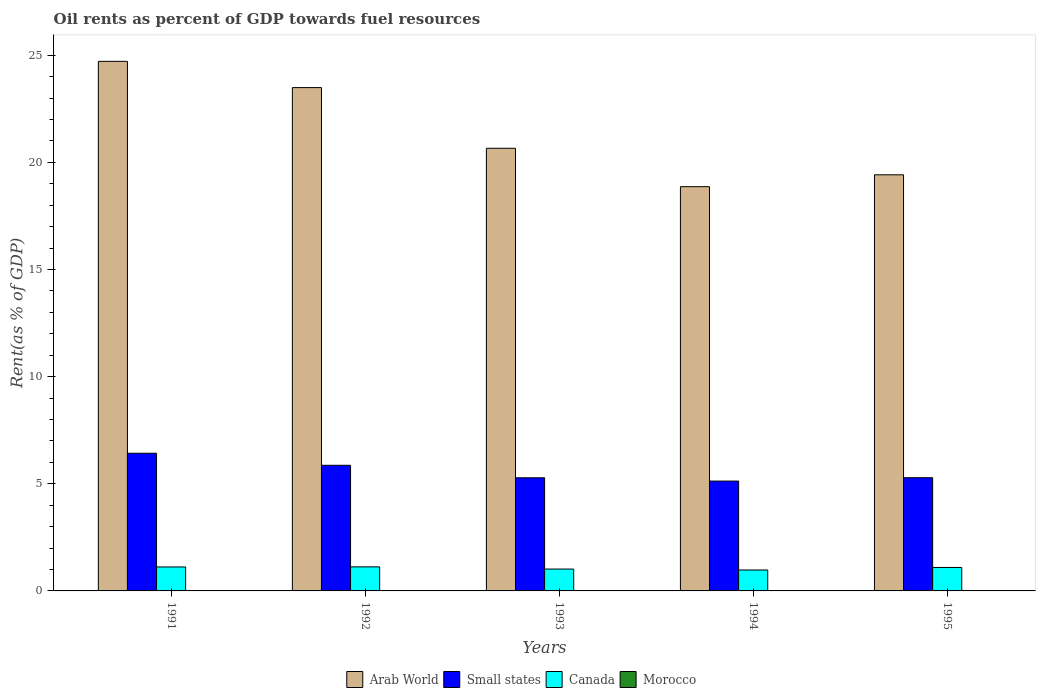How many groups of bars are there?
Provide a short and direct response. 5. Are the number of bars on each tick of the X-axis equal?
Keep it short and to the point. Yes. How many bars are there on the 5th tick from the left?
Make the answer very short. 4. In how many cases, is the number of bars for a given year not equal to the number of legend labels?
Ensure brevity in your answer.  0. What is the oil rent in Arab World in 1995?
Keep it short and to the point. 19.42. Across all years, what is the maximum oil rent in Morocco?
Give a very brief answer. 0. Across all years, what is the minimum oil rent in Arab World?
Your response must be concise. 18.86. In which year was the oil rent in Morocco maximum?
Offer a very short reply. 1991. What is the total oil rent in Arab World in the graph?
Provide a succinct answer. 107.13. What is the difference between the oil rent in Morocco in 1993 and that in 1995?
Your answer should be compact. 0. What is the difference between the oil rent in Arab World in 1993 and the oil rent in Small states in 1994?
Your response must be concise. 15.53. What is the average oil rent in Canada per year?
Give a very brief answer. 1.07. In the year 1991, what is the difference between the oil rent in Morocco and oil rent in Small states?
Your answer should be compact. -6.42. In how many years, is the oil rent in Morocco greater than 10 %?
Make the answer very short. 0. What is the ratio of the oil rent in Small states in 1993 to that in 1994?
Provide a short and direct response. 1.03. Is the oil rent in Morocco in 1993 less than that in 1995?
Provide a succinct answer. No. Is the difference between the oil rent in Morocco in 1992 and 1995 greater than the difference between the oil rent in Small states in 1992 and 1995?
Provide a short and direct response. No. What is the difference between the highest and the second highest oil rent in Canada?
Give a very brief answer. 0. What is the difference between the highest and the lowest oil rent in Canada?
Give a very brief answer. 0.15. In how many years, is the oil rent in Arab World greater than the average oil rent in Arab World taken over all years?
Provide a short and direct response. 2. Is the sum of the oil rent in Small states in 1994 and 1995 greater than the maximum oil rent in Morocco across all years?
Your answer should be very brief. Yes. Is it the case that in every year, the sum of the oil rent in Canada and oil rent in Small states is greater than the sum of oil rent in Morocco and oil rent in Arab World?
Your answer should be very brief. No. What does the 1st bar from the left in 1995 represents?
Ensure brevity in your answer.  Arab World. What does the 4th bar from the right in 1995 represents?
Ensure brevity in your answer.  Arab World. Is it the case that in every year, the sum of the oil rent in Canada and oil rent in Morocco is greater than the oil rent in Small states?
Your answer should be very brief. No. How many bars are there?
Your answer should be compact. 20. How many years are there in the graph?
Provide a succinct answer. 5. Does the graph contain any zero values?
Your response must be concise. No. Where does the legend appear in the graph?
Offer a terse response. Bottom center. How are the legend labels stacked?
Your answer should be very brief. Horizontal. What is the title of the graph?
Offer a terse response. Oil rents as percent of GDP towards fuel resources. Does "Micronesia" appear as one of the legend labels in the graph?
Keep it short and to the point. No. What is the label or title of the Y-axis?
Your answer should be very brief. Rent(as % of GDP). What is the Rent(as % of GDP) in Arab World in 1991?
Your response must be concise. 24.71. What is the Rent(as % of GDP) in Small states in 1991?
Provide a short and direct response. 6.42. What is the Rent(as % of GDP) in Canada in 1991?
Ensure brevity in your answer.  1.12. What is the Rent(as % of GDP) of Morocco in 1991?
Offer a terse response. 0. What is the Rent(as % of GDP) in Arab World in 1992?
Keep it short and to the point. 23.49. What is the Rent(as % of GDP) in Small states in 1992?
Your answer should be compact. 5.86. What is the Rent(as % of GDP) of Canada in 1992?
Your answer should be compact. 1.12. What is the Rent(as % of GDP) of Morocco in 1992?
Your answer should be compact. 0. What is the Rent(as % of GDP) in Arab World in 1993?
Ensure brevity in your answer.  20.66. What is the Rent(as % of GDP) of Small states in 1993?
Offer a very short reply. 5.28. What is the Rent(as % of GDP) of Canada in 1993?
Provide a short and direct response. 1.02. What is the Rent(as % of GDP) of Morocco in 1993?
Ensure brevity in your answer.  0. What is the Rent(as % of GDP) of Arab World in 1994?
Offer a terse response. 18.86. What is the Rent(as % of GDP) in Small states in 1994?
Make the answer very short. 5.13. What is the Rent(as % of GDP) in Canada in 1994?
Ensure brevity in your answer.  0.98. What is the Rent(as % of GDP) in Morocco in 1994?
Offer a terse response. 0. What is the Rent(as % of GDP) in Arab World in 1995?
Offer a terse response. 19.42. What is the Rent(as % of GDP) of Small states in 1995?
Ensure brevity in your answer.  5.28. What is the Rent(as % of GDP) in Canada in 1995?
Provide a succinct answer. 1.09. What is the Rent(as % of GDP) in Morocco in 1995?
Your answer should be very brief. 0. Across all years, what is the maximum Rent(as % of GDP) in Arab World?
Give a very brief answer. 24.71. Across all years, what is the maximum Rent(as % of GDP) of Small states?
Ensure brevity in your answer.  6.42. Across all years, what is the maximum Rent(as % of GDP) in Canada?
Provide a succinct answer. 1.12. Across all years, what is the maximum Rent(as % of GDP) in Morocco?
Offer a very short reply. 0. Across all years, what is the minimum Rent(as % of GDP) in Arab World?
Ensure brevity in your answer.  18.86. Across all years, what is the minimum Rent(as % of GDP) of Small states?
Your response must be concise. 5.13. Across all years, what is the minimum Rent(as % of GDP) in Canada?
Your answer should be compact. 0.98. Across all years, what is the minimum Rent(as % of GDP) in Morocco?
Keep it short and to the point. 0. What is the total Rent(as % of GDP) in Arab World in the graph?
Your answer should be very brief. 107.13. What is the total Rent(as % of GDP) of Small states in the graph?
Ensure brevity in your answer.  27.97. What is the total Rent(as % of GDP) in Canada in the graph?
Ensure brevity in your answer.  5.33. What is the total Rent(as % of GDP) in Morocco in the graph?
Ensure brevity in your answer.  0.02. What is the difference between the Rent(as % of GDP) of Arab World in 1991 and that in 1992?
Make the answer very short. 1.22. What is the difference between the Rent(as % of GDP) of Small states in 1991 and that in 1992?
Offer a very short reply. 0.56. What is the difference between the Rent(as % of GDP) in Canada in 1991 and that in 1992?
Keep it short and to the point. -0. What is the difference between the Rent(as % of GDP) of Morocco in 1991 and that in 1992?
Your answer should be very brief. 0. What is the difference between the Rent(as % of GDP) in Arab World in 1991 and that in 1993?
Your response must be concise. 4.06. What is the difference between the Rent(as % of GDP) in Small states in 1991 and that in 1993?
Ensure brevity in your answer.  1.15. What is the difference between the Rent(as % of GDP) in Canada in 1991 and that in 1993?
Your answer should be compact. 0.1. What is the difference between the Rent(as % of GDP) in Morocco in 1991 and that in 1993?
Your response must be concise. 0. What is the difference between the Rent(as % of GDP) in Arab World in 1991 and that in 1994?
Give a very brief answer. 5.85. What is the difference between the Rent(as % of GDP) in Small states in 1991 and that in 1994?
Ensure brevity in your answer.  1.3. What is the difference between the Rent(as % of GDP) of Canada in 1991 and that in 1994?
Provide a short and direct response. 0.14. What is the difference between the Rent(as % of GDP) of Morocco in 1991 and that in 1994?
Make the answer very short. 0. What is the difference between the Rent(as % of GDP) of Arab World in 1991 and that in 1995?
Provide a succinct answer. 5.29. What is the difference between the Rent(as % of GDP) in Small states in 1991 and that in 1995?
Provide a succinct answer. 1.14. What is the difference between the Rent(as % of GDP) in Canada in 1991 and that in 1995?
Keep it short and to the point. 0.02. What is the difference between the Rent(as % of GDP) in Morocco in 1991 and that in 1995?
Your response must be concise. 0. What is the difference between the Rent(as % of GDP) of Arab World in 1992 and that in 1993?
Your response must be concise. 2.83. What is the difference between the Rent(as % of GDP) in Small states in 1992 and that in 1993?
Your answer should be very brief. 0.58. What is the difference between the Rent(as % of GDP) in Canada in 1992 and that in 1993?
Offer a terse response. 0.1. What is the difference between the Rent(as % of GDP) in Morocco in 1992 and that in 1993?
Offer a terse response. 0. What is the difference between the Rent(as % of GDP) in Arab World in 1992 and that in 1994?
Your answer should be very brief. 4.62. What is the difference between the Rent(as % of GDP) of Small states in 1992 and that in 1994?
Offer a terse response. 0.74. What is the difference between the Rent(as % of GDP) of Canada in 1992 and that in 1994?
Provide a short and direct response. 0.15. What is the difference between the Rent(as % of GDP) in Morocco in 1992 and that in 1994?
Provide a short and direct response. 0. What is the difference between the Rent(as % of GDP) of Arab World in 1992 and that in 1995?
Make the answer very short. 4.07. What is the difference between the Rent(as % of GDP) of Small states in 1992 and that in 1995?
Provide a short and direct response. 0.58. What is the difference between the Rent(as % of GDP) in Canada in 1992 and that in 1995?
Provide a succinct answer. 0.03. What is the difference between the Rent(as % of GDP) of Morocco in 1992 and that in 1995?
Your response must be concise. 0. What is the difference between the Rent(as % of GDP) of Arab World in 1993 and that in 1994?
Give a very brief answer. 1.79. What is the difference between the Rent(as % of GDP) of Small states in 1993 and that in 1994?
Your answer should be very brief. 0.15. What is the difference between the Rent(as % of GDP) of Canada in 1993 and that in 1994?
Provide a short and direct response. 0.04. What is the difference between the Rent(as % of GDP) of Morocco in 1993 and that in 1994?
Keep it short and to the point. 0. What is the difference between the Rent(as % of GDP) in Arab World in 1993 and that in 1995?
Make the answer very short. 1.24. What is the difference between the Rent(as % of GDP) of Small states in 1993 and that in 1995?
Provide a succinct answer. -0. What is the difference between the Rent(as % of GDP) in Canada in 1993 and that in 1995?
Your answer should be very brief. -0.07. What is the difference between the Rent(as % of GDP) in Morocco in 1993 and that in 1995?
Give a very brief answer. 0. What is the difference between the Rent(as % of GDP) of Arab World in 1994 and that in 1995?
Your response must be concise. -0.55. What is the difference between the Rent(as % of GDP) of Small states in 1994 and that in 1995?
Your answer should be very brief. -0.16. What is the difference between the Rent(as % of GDP) in Canada in 1994 and that in 1995?
Offer a terse response. -0.12. What is the difference between the Rent(as % of GDP) of Morocco in 1994 and that in 1995?
Provide a short and direct response. 0. What is the difference between the Rent(as % of GDP) of Arab World in 1991 and the Rent(as % of GDP) of Small states in 1992?
Your answer should be very brief. 18.85. What is the difference between the Rent(as % of GDP) of Arab World in 1991 and the Rent(as % of GDP) of Canada in 1992?
Provide a short and direct response. 23.59. What is the difference between the Rent(as % of GDP) of Arab World in 1991 and the Rent(as % of GDP) of Morocco in 1992?
Give a very brief answer. 24.71. What is the difference between the Rent(as % of GDP) in Small states in 1991 and the Rent(as % of GDP) in Canada in 1992?
Give a very brief answer. 5.3. What is the difference between the Rent(as % of GDP) of Small states in 1991 and the Rent(as % of GDP) of Morocco in 1992?
Keep it short and to the point. 6.42. What is the difference between the Rent(as % of GDP) of Canada in 1991 and the Rent(as % of GDP) of Morocco in 1992?
Give a very brief answer. 1.11. What is the difference between the Rent(as % of GDP) in Arab World in 1991 and the Rent(as % of GDP) in Small states in 1993?
Your response must be concise. 19.43. What is the difference between the Rent(as % of GDP) of Arab World in 1991 and the Rent(as % of GDP) of Canada in 1993?
Your answer should be very brief. 23.69. What is the difference between the Rent(as % of GDP) in Arab World in 1991 and the Rent(as % of GDP) in Morocco in 1993?
Provide a short and direct response. 24.71. What is the difference between the Rent(as % of GDP) of Small states in 1991 and the Rent(as % of GDP) of Canada in 1993?
Offer a very short reply. 5.4. What is the difference between the Rent(as % of GDP) in Small states in 1991 and the Rent(as % of GDP) in Morocco in 1993?
Keep it short and to the point. 6.42. What is the difference between the Rent(as % of GDP) in Canada in 1991 and the Rent(as % of GDP) in Morocco in 1993?
Your response must be concise. 1.12. What is the difference between the Rent(as % of GDP) of Arab World in 1991 and the Rent(as % of GDP) of Small states in 1994?
Your answer should be compact. 19.59. What is the difference between the Rent(as % of GDP) in Arab World in 1991 and the Rent(as % of GDP) in Canada in 1994?
Provide a short and direct response. 23.73. What is the difference between the Rent(as % of GDP) in Arab World in 1991 and the Rent(as % of GDP) in Morocco in 1994?
Your answer should be very brief. 24.71. What is the difference between the Rent(as % of GDP) in Small states in 1991 and the Rent(as % of GDP) in Canada in 1994?
Provide a succinct answer. 5.45. What is the difference between the Rent(as % of GDP) of Small states in 1991 and the Rent(as % of GDP) of Morocco in 1994?
Provide a short and direct response. 6.42. What is the difference between the Rent(as % of GDP) in Canada in 1991 and the Rent(as % of GDP) in Morocco in 1994?
Your answer should be very brief. 1.12. What is the difference between the Rent(as % of GDP) of Arab World in 1991 and the Rent(as % of GDP) of Small states in 1995?
Your answer should be compact. 19.43. What is the difference between the Rent(as % of GDP) of Arab World in 1991 and the Rent(as % of GDP) of Canada in 1995?
Provide a short and direct response. 23.62. What is the difference between the Rent(as % of GDP) of Arab World in 1991 and the Rent(as % of GDP) of Morocco in 1995?
Keep it short and to the point. 24.71. What is the difference between the Rent(as % of GDP) in Small states in 1991 and the Rent(as % of GDP) in Canada in 1995?
Your answer should be very brief. 5.33. What is the difference between the Rent(as % of GDP) of Small states in 1991 and the Rent(as % of GDP) of Morocco in 1995?
Ensure brevity in your answer.  6.42. What is the difference between the Rent(as % of GDP) of Canada in 1991 and the Rent(as % of GDP) of Morocco in 1995?
Your answer should be compact. 1.12. What is the difference between the Rent(as % of GDP) of Arab World in 1992 and the Rent(as % of GDP) of Small states in 1993?
Keep it short and to the point. 18.21. What is the difference between the Rent(as % of GDP) in Arab World in 1992 and the Rent(as % of GDP) in Canada in 1993?
Keep it short and to the point. 22.47. What is the difference between the Rent(as % of GDP) of Arab World in 1992 and the Rent(as % of GDP) of Morocco in 1993?
Make the answer very short. 23.48. What is the difference between the Rent(as % of GDP) in Small states in 1992 and the Rent(as % of GDP) in Canada in 1993?
Provide a succinct answer. 4.84. What is the difference between the Rent(as % of GDP) of Small states in 1992 and the Rent(as % of GDP) of Morocco in 1993?
Your answer should be compact. 5.86. What is the difference between the Rent(as % of GDP) of Canada in 1992 and the Rent(as % of GDP) of Morocco in 1993?
Provide a short and direct response. 1.12. What is the difference between the Rent(as % of GDP) of Arab World in 1992 and the Rent(as % of GDP) of Small states in 1994?
Offer a very short reply. 18.36. What is the difference between the Rent(as % of GDP) in Arab World in 1992 and the Rent(as % of GDP) in Canada in 1994?
Offer a terse response. 22.51. What is the difference between the Rent(as % of GDP) of Arab World in 1992 and the Rent(as % of GDP) of Morocco in 1994?
Provide a short and direct response. 23.48. What is the difference between the Rent(as % of GDP) in Small states in 1992 and the Rent(as % of GDP) in Canada in 1994?
Offer a very short reply. 4.89. What is the difference between the Rent(as % of GDP) in Small states in 1992 and the Rent(as % of GDP) in Morocco in 1994?
Provide a short and direct response. 5.86. What is the difference between the Rent(as % of GDP) of Canada in 1992 and the Rent(as % of GDP) of Morocco in 1994?
Your response must be concise. 1.12. What is the difference between the Rent(as % of GDP) of Arab World in 1992 and the Rent(as % of GDP) of Small states in 1995?
Give a very brief answer. 18.2. What is the difference between the Rent(as % of GDP) in Arab World in 1992 and the Rent(as % of GDP) in Canada in 1995?
Make the answer very short. 22.39. What is the difference between the Rent(as % of GDP) in Arab World in 1992 and the Rent(as % of GDP) in Morocco in 1995?
Your answer should be very brief. 23.48. What is the difference between the Rent(as % of GDP) in Small states in 1992 and the Rent(as % of GDP) in Canada in 1995?
Ensure brevity in your answer.  4.77. What is the difference between the Rent(as % of GDP) of Small states in 1992 and the Rent(as % of GDP) of Morocco in 1995?
Offer a very short reply. 5.86. What is the difference between the Rent(as % of GDP) in Canada in 1992 and the Rent(as % of GDP) in Morocco in 1995?
Offer a terse response. 1.12. What is the difference between the Rent(as % of GDP) of Arab World in 1993 and the Rent(as % of GDP) of Small states in 1994?
Ensure brevity in your answer.  15.53. What is the difference between the Rent(as % of GDP) in Arab World in 1993 and the Rent(as % of GDP) in Canada in 1994?
Provide a succinct answer. 19.68. What is the difference between the Rent(as % of GDP) in Arab World in 1993 and the Rent(as % of GDP) in Morocco in 1994?
Provide a short and direct response. 20.65. What is the difference between the Rent(as % of GDP) in Small states in 1993 and the Rent(as % of GDP) in Canada in 1994?
Offer a very short reply. 4.3. What is the difference between the Rent(as % of GDP) in Small states in 1993 and the Rent(as % of GDP) in Morocco in 1994?
Provide a succinct answer. 5.28. What is the difference between the Rent(as % of GDP) in Canada in 1993 and the Rent(as % of GDP) in Morocco in 1994?
Give a very brief answer. 1.02. What is the difference between the Rent(as % of GDP) of Arab World in 1993 and the Rent(as % of GDP) of Small states in 1995?
Keep it short and to the point. 15.37. What is the difference between the Rent(as % of GDP) of Arab World in 1993 and the Rent(as % of GDP) of Canada in 1995?
Offer a very short reply. 19.56. What is the difference between the Rent(as % of GDP) in Arab World in 1993 and the Rent(as % of GDP) in Morocco in 1995?
Your answer should be very brief. 20.65. What is the difference between the Rent(as % of GDP) in Small states in 1993 and the Rent(as % of GDP) in Canada in 1995?
Your answer should be very brief. 4.18. What is the difference between the Rent(as % of GDP) in Small states in 1993 and the Rent(as % of GDP) in Morocco in 1995?
Offer a very short reply. 5.28. What is the difference between the Rent(as % of GDP) in Canada in 1993 and the Rent(as % of GDP) in Morocco in 1995?
Your answer should be very brief. 1.02. What is the difference between the Rent(as % of GDP) of Arab World in 1994 and the Rent(as % of GDP) of Small states in 1995?
Make the answer very short. 13.58. What is the difference between the Rent(as % of GDP) in Arab World in 1994 and the Rent(as % of GDP) in Canada in 1995?
Provide a succinct answer. 17.77. What is the difference between the Rent(as % of GDP) in Arab World in 1994 and the Rent(as % of GDP) in Morocco in 1995?
Offer a very short reply. 18.86. What is the difference between the Rent(as % of GDP) in Small states in 1994 and the Rent(as % of GDP) in Canada in 1995?
Ensure brevity in your answer.  4.03. What is the difference between the Rent(as % of GDP) in Small states in 1994 and the Rent(as % of GDP) in Morocco in 1995?
Provide a succinct answer. 5.12. What is the difference between the Rent(as % of GDP) of Canada in 1994 and the Rent(as % of GDP) of Morocco in 1995?
Your answer should be compact. 0.97. What is the average Rent(as % of GDP) of Arab World per year?
Provide a succinct answer. 21.43. What is the average Rent(as % of GDP) in Small states per year?
Give a very brief answer. 5.59. What is the average Rent(as % of GDP) of Canada per year?
Provide a succinct answer. 1.07. What is the average Rent(as % of GDP) of Morocco per year?
Offer a very short reply. 0. In the year 1991, what is the difference between the Rent(as % of GDP) in Arab World and Rent(as % of GDP) in Small states?
Make the answer very short. 18.29. In the year 1991, what is the difference between the Rent(as % of GDP) in Arab World and Rent(as % of GDP) in Canada?
Provide a short and direct response. 23.59. In the year 1991, what is the difference between the Rent(as % of GDP) in Arab World and Rent(as % of GDP) in Morocco?
Keep it short and to the point. 24.71. In the year 1991, what is the difference between the Rent(as % of GDP) of Small states and Rent(as % of GDP) of Canada?
Your response must be concise. 5.31. In the year 1991, what is the difference between the Rent(as % of GDP) of Small states and Rent(as % of GDP) of Morocco?
Provide a succinct answer. 6.42. In the year 1991, what is the difference between the Rent(as % of GDP) of Canada and Rent(as % of GDP) of Morocco?
Give a very brief answer. 1.11. In the year 1992, what is the difference between the Rent(as % of GDP) in Arab World and Rent(as % of GDP) in Small states?
Make the answer very short. 17.62. In the year 1992, what is the difference between the Rent(as % of GDP) of Arab World and Rent(as % of GDP) of Canada?
Provide a succinct answer. 22.36. In the year 1992, what is the difference between the Rent(as % of GDP) in Arab World and Rent(as % of GDP) in Morocco?
Keep it short and to the point. 23.48. In the year 1992, what is the difference between the Rent(as % of GDP) in Small states and Rent(as % of GDP) in Canada?
Offer a terse response. 4.74. In the year 1992, what is the difference between the Rent(as % of GDP) in Small states and Rent(as % of GDP) in Morocco?
Give a very brief answer. 5.86. In the year 1992, what is the difference between the Rent(as % of GDP) in Canada and Rent(as % of GDP) in Morocco?
Provide a short and direct response. 1.12. In the year 1993, what is the difference between the Rent(as % of GDP) of Arab World and Rent(as % of GDP) of Small states?
Provide a succinct answer. 15.38. In the year 1993, what is the difference between the Rent(as % of GDP) in Arab World and Rent(as % of GDP) in Canada?
Provide a short and direct response. 19.64. In the year 1993, what is the difference between the Rent(as % of GDP) in Arab World and Rent(as % of GDP) in Morocco?
Keep it short and to the point. 20.65. In the year 1993, what is the difference between the Rent(as % of GDP) in Small states and Rent(as % of GDP) in Canada?
Your answer should be compact. 4.26. In the year 1993, what is the difference between the Rent(as % of GDP) in Small states and Rent(as % of GDP) in Morocco?
Keep it short and to the point. 5.28. In the year 1993, what is the difference between the Rent(as % of GDP) in Canada and Rent(as % of GDP) in Morocco?
Offer a very short reply. 1.02. In the year 1994, what is the difference between the Rent(as % of GDP) of Arab World and Rent(as % of GDP) of Small states?
Ensure brevity in your answer.  13.74. In the year 1994, what is the difference between the Rent(as % of GDP) of Arab World and Rent(as % of GDP) of Canada?
Offer a very short reply. 17.89. In the year 1994, what is the difference between the Rent(as % of GDP) in Arab World and Rent(as % of GDP) in Morocco?
Keep it short and to the point. 18.86. In the year 1994, what is the difference between the Rent(as % of GDP) of Small states and Rent(as % of GDP) of Canada?
Make the answer very short. 4.15. In the year 1994, what is the difference between the Rent(as % of GDP) in Small states and Rent(as % of GDP) in Morocco?
Offer a terse response. 5.12. In the year 1994, what is the difference between the Rent(as % of GDP) of Canada and Rent(as % of GDP) of Morocco?
Provide a short and direct response. 0.97. In the year 1995, what is the difference between the Rent(as % of GDP) of Arab World and Rent(as % of GDP) of Small states?
Your response must be concise. 14.13. In the year 1995, what is the difference between the Rent(as % of GDP) in Arab World and Rent(as % of GDP) in Canada?
Ensure brevity in your answer.  18.32. In the year 1995, what is the difference between the Rent(as % of GDP) in Arab World and Rent(as % of GDP) in Morocco?
Give a very brief answer. 19.42. In the year 1995, what is the difference between the Rent(as % of GDP) of Small states and Rent(as % of GDP) of Canada?
Your answer should be compact. 4.19. In the year 1995, what is the difference between the Rent(as % of GDP) in Small states and Rent(as % of GDP) in Morocco?
Offer a terse response. 5.28. In the year 1995, what is the difference between the Rent(as % of GDP) in Canada and Rent(as % of GDP) in Morocco?
Ensure brevity in your answer.  1.09. What is the ratio of the Rent(as % of GDP) of Arab World in 1991 to that in 1992?
Your response must be concise. 1.05. What is the ratio of the Rent(as % of GDP) in Small states in 1991 to that in 1992?
Give a very brief answer. 1.1. What is the ratio of the Rent(as % of GDP) of Canada in 1991 to that in 1992?
Ensure brevity in your answer.  1. What is the ratio of the Rent(as % of GDP) of Morocco in 1991 to that in 1992?
Your answer should be compact. 1.17. What is the ratio of the Rent(as % of GDP) of Arab World in 1991 to that in 1993?
Give a very brief answer. 1.2. What is the ratio of the Rent(as % of GDP) in Small states in 1991 to that in 1993?
Make the answer very short. 1.22. What is the ratio of the Rent(as % of GDP) in Canada in 1991 to that in 1993?
Your answer should be very brief. 1.1. What is the ratio of the Rent(as % of GDP) of Morocco in 1991 to that in 1993?
Offer a terse response. 1.38. What is the ratio of the Rent(as % of GDP) in Arab World in 1991 to that in 1994?
Provide a short and direct response. 1.31. What is the ratio of the Rent(as % of GDP) in Small states in 1991 to that in 1994?
Your answer should be compact. 1.25. What is the ratio of the Rent(as % of GDP) of Canada in 1991 to that in 1994?
Give a very brief answer. 1.15. What is the ratio of the Rent(as % of GDP) in Morocco in 1991 to that in 1994?
Provide a succinct answer. 2.09. What is the ratio of the Rent(as % of GDP) in Arab World in 1991 to that in 1995?
Provide a succinct answer. 1.27. What is the ratio of the Rent(as % of GDP) of Small states in 1991 to that in 1995?
Make the answer very short. 1.22. What is the ratio of the Rent(as % of GDP) in Morocco in 1991 to that in 1995?
Your response must be concise. 3.32. What is the ratio of the Rent(as % of GDP) of Arab World in 1992 to that in 1993?
Make the answer very short. 1.14. What is the ratio of the Rent(as % of GDP) of Small states in 1992 to that in 1993?
Keep it short and to the point. 1.11. What is the ratio of the Rent(as % of GDP) of Canada in 1992 to that in 1993?
Provide a short and direct response. 1.1. What is the ratio of the Rent(as % of GDP) in Morocco in 1992 to that in 1993?
Ensure brevity in your answer.  1.18. What is the ratio of the Rent(as % of GDP) of Arab World in 1992 to that in 1994?
Offer a very short reply. 1.25. What is the ratio of the Rent(as % of GDP) in Small states in 1992 to that in 1994?
Offer a terse response. 1.14. What is the ratio of the Rent(as % of GDP) in Canada in 1992 to that in 1994?
Make the answer very short. 1.15. What is the ratio of the Rent(as % of GDP) in Morocco in 1992 to that in 1994?
Keep it short and to the point. 1.79. What is the ratio of the Rent(as % of GDP) of Arab World in 1992 to that in 1995?
Make the answer very short. 1.21. What is the ratio of the Rent(as % of GDP) in Small states in 1992 to that in 1995?
Provide a short and direct response. 1.11. What is the ratio of the Rent(as % of GDP) in Canada in 1992 to that in 1995?
Your answer should be very brief. 1.03. What is the ratio of the Rent(as % of GDP) of Morocco in 1992 to that in 1995?
Keep it short and to the point. 2.84. What is the ratio of the Rent(as % of GDP) in Arab World in 1993 to that in 1994?
Provide a succinct answer. 1.09. What is the ratio of the Rent(as % of GDP) of Small states in 1993 to that in 1994?
Offer a very short reply. 1.03. What is the ratio of the Rent(as % of GDP) of Canada in 1993 to that in 1994?
Make the answer very short. 1.04. What is the ratio of the Rent(as % of GDP) of Morocco in 1993 to that in 1994?
Offer a terse response. 1.51. What is the ratio of the Rent(as % of GDP) of Arab World in 1993 to that in 1995?
Ensure brevity in your answer.  1.06. What is the ratio of the Rent(as % of GDP) of Canada in 1993 to that in 1995?
Ensure brevity in your answer.  0.93. What is the ratio of the Rent(as % of GDP) in Morocco in 1993 to that in 1995?
Provide a succinct answer. 2.4. What is the ratio of the Rent(as % of GDP) in Arab World in 1994 to that in 1995?
Ensure brevity in your answer.  0.97. What is the ratio of the Rent(as % of GDP) of Small states in 1994 to that in 1995?
Give a very brief answer. 0.97. What is the ratio of the Rent(as % of GDP) of Canada in 1994 to that in 1995?
Make the answer very short. 0.89. What is the ratio of the Rent(as % of GDP) in Morocco in 1994 to that in 1995?
Give a very brief answer. 1.59. What is the difference between the highest and the second highest Rent(as % of GDP) of Arab World?
Your answer should be compact. 1.22. What is the difference between the highest and the second highest Rent(as % of GDP) of Small states?
Keep it short and to the point. 0.56. What is the difference between the highest and the second highest Rent(as % of GDP) in Canada?
Provide a short and direct response. 0. What is the difference between the highest and the second highest Rent(as % of GDP) in Morocco?
Provide a succinct answer. 0. What is the difference between the highest and the lowest Rent(as % of GDP) of Arab World?
Offer a terse response. 5.85. What is the difference between the highest and the lowest Rent(as % of GDP) in Small states?
Provide a succinct answer. 1.3. What is the difference between the highest and the lowest Rent(as % of GDP) in Canada?
Give a very brief answer. 0.15. What is the difference between the highest and the lowest Rent(as % of GDP) in Morocco?
Make the answer very short. 0. 